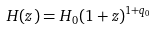<formula> <loc_0><loc_0><loc_500><loc_500>H ( z ) = H _ { 0 } ( 1 + z ) ^ { 1 + q _ { 0 } }</formula> 